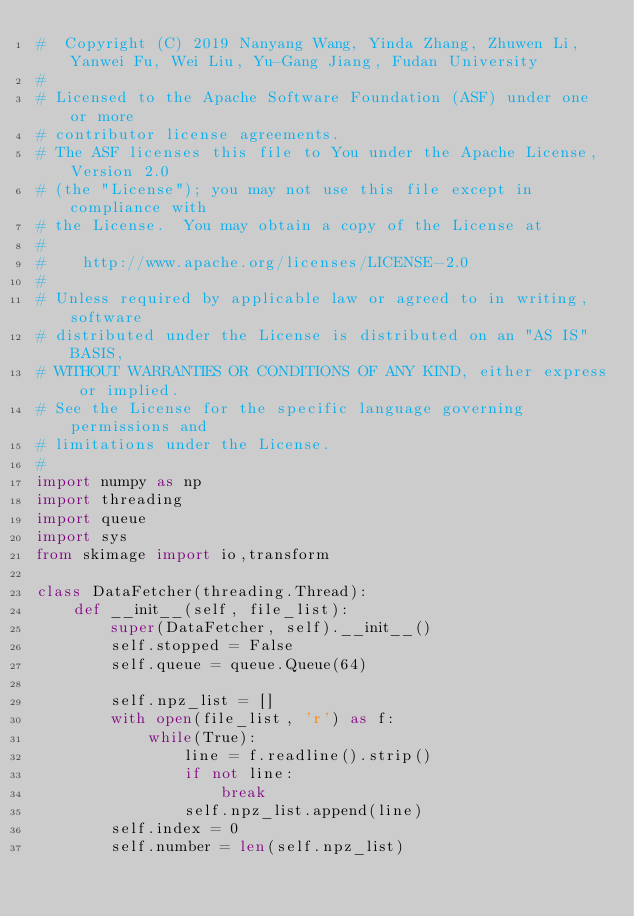<code> <loc_0><loc_0><loc_500><loc_500><_Python_>#  Copyright (C) 2019 Nanyang Wang, Yinda Zhang, Zhuwen Li, Yanwei Fu, Wei Liu, Yu-Gang Jiang, Fudan University
#
# Licensed to the Apache Software Foundation (ASF) under one or more
# contributor license agreements.
# The ASF licenses this file to You under the Apache License, Version 2.0
# (the "License"); you may not use this file except in compliance with
# the License.  You may obtain a copy of the License at
#
#    http://www.apache.org/licenses/LICENSE-2.0
#
# Unless required by applicable law or agreed to in writing, software
# distributed under the License is distributed on an "AS IS" BASIS,
# WITHOUT WARRANTIES OR CONDITIONS OF ANY KIND, either express or implied.
# See the License for the specific language governing permissions and
# limitations under the License.
#
import numpy as np
import threading
import queue
import sys
from skimage import io,transform

class DataFetcher(threading.Thread):
	def __init__(self, file_list):
		super(DataFetcher, self).__init__()
		self.stopped = False
		self.queue = queue.Queue(64)

		self.npz_list = []
		with open(file_list, 'r') as f:
			while(True):
				line = f.readline().strip()
				if not line:
					break
				self.npz_list.append(line)
		self.index = 0
		self.number = len(self.npz_list)</code> 